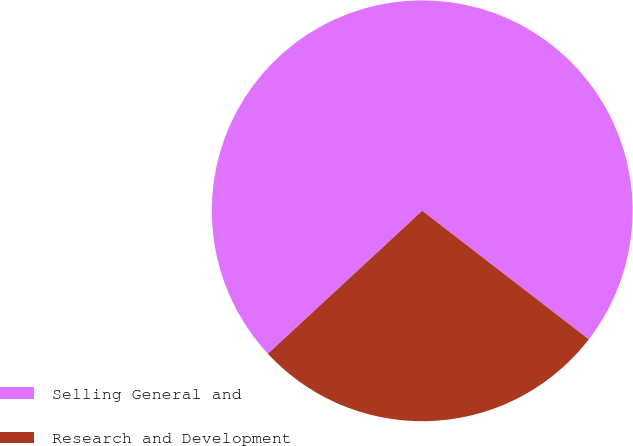Convert chart to OTSL. <chart><loc_0><loc_0><loc_500><loc_500><pie_chart><fcel>Selling General and<fcel>Research and Development<nl><fcel>72.35%<fcel>27.65%<nl></chart> 